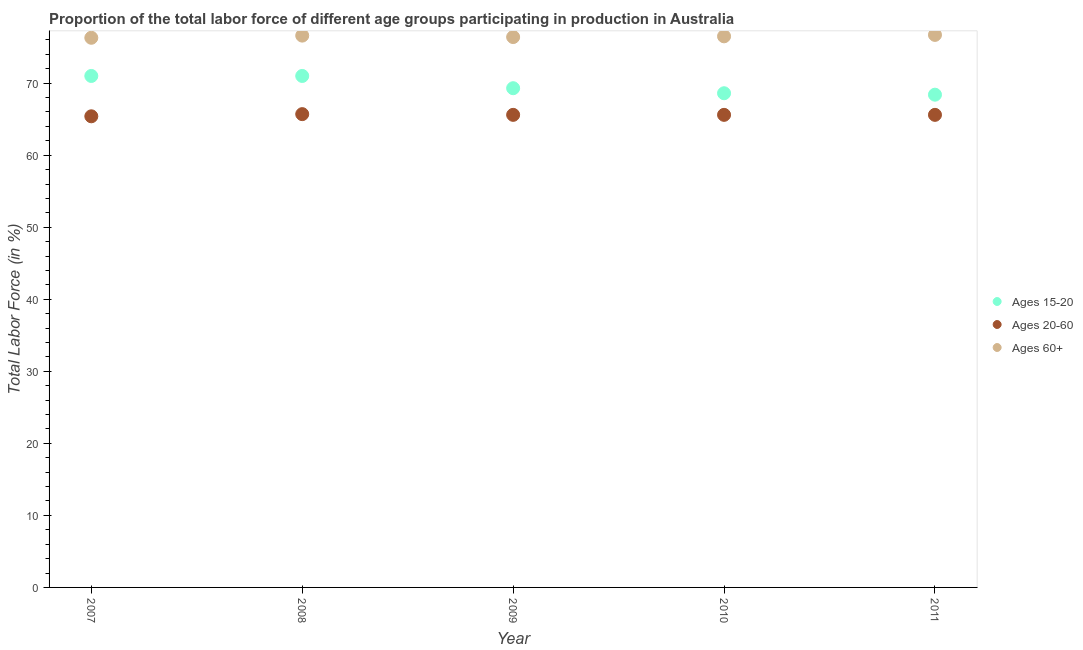How many different coloured dotlines are there?
Ensure brevity in your answer.  3. Is the number of dotlines equal to the number of legend labels?
Make the answer very short. Yes. What is the percentage of labor force above age 60 in 2007?
Keep it short and to the point. 76.3. Across all years, what is the maximum percentage of labor force above age 60?
Give a very brief answer. 76.7. Across all years, what is the minimum percentage of labor force within the age group 20-60?
Provide a succinct answer. 65.4. In which year was the percentage of labor force within the age group 15-20 maximum?
Offer a very short reply. 2007. What is the total percentage of labor force within the age group 20-60 in the graph?
Offer a terse response. 327.9. What is the difference between the percentage of labor force within the age group 20-60 in 2008 and that in 2009?
Make the answer very short. 0.1. What is the average percentage of labor force within the age group 20-60 per year?
Offer a very short reply. 65.58. In the year 2011, what is the difference between the percentage of labor force within the age group 20-60 and percentage of labor force above age 60?
Offer a very short reply. -11.1. What is the ratio of the percentage of labor force above age 60 in 2008 to that in 2011?
Provide a short and direct response. 1. What is the difference between the highest and the second highest percentage of labor force within the age group 20-60?
Your answer should be compact. 0.1. What is the difference between the highest and the lowest percentage of labor force within the age group 15-20?
Offer a terse response. 2.6. In how many years, is the percentage of labor force within the age group 20-60 greater than the average percentage of labor force within the age group 20-60 taken over all years?
Your answer should be compact. 4. Is the sum of the percentage of labor force within the age group 20-60 in 2009 and 2011 greater than the maximum percentage of labor force above age 60 across all years?
Offer a terse response. Yes. Is it the case that in every year, the sum of the percentage of labor force within the age group 15-20 and percentage of labor force within the age group 20-60 is greater than the percentage of labor force above age 60?
Provide a succinct answer. Yes. Is the percentage of labor force above age 60 strictly greater than the percentage of labor force within the age group 20-60 over the years?
Provide a succinct answer. Yes. Is the percentage of labor force within the age group 20-60 strictly less than the percentage of labor force within the age group 15-20 over the years?
Offer a very short reply. Yes. How many dotlines are there?
Offer a very short reply. 3. What is the difference between two consecutive major ticks on the Y-axis?
Make the answer very short. 10. Does the graph contain grids?
Your response must be concise. No. Where does the legend appear in the graph?
Make the answer very short. Center right. How many legend labels are there?
Your answer should be very brief. 3. What is the title of the graph?
Make the answer very short. Proportion of the total labor force of different age groups participating in production in Australia. What is the label or title of the X-axis?
Offer a very short reply. Year. What is the label or title of the Y-axis?
Ensure brevity in your answer.  Total Labor Force (in %). What is the Total Labor Force (in %) of Ages 20-60 in 2007?
Provide a short and direct response. 65.4. What is the Total Labor Force (in %) of Ages 60+ in 2007?
Your response must be concise. 76.3. What is the Total Labor Force (in %) in Ages 20-60 in 2008?
Provide a short and direct response. 65.7. What is the Total Labor Force (in %) in Ages 60+ in 2008?
Keep it short and to the point. 76.6. What is the Total Labor Force (in %) in Ages 15-20 in 2009?
Offer a terse response. 69.3. What is the Total Labor Force (in %) of Ages 20-60 in 2009?
Provide a succinct answer. 65.6. What is the Total Labor Force (in %) of Ages 60+ in 2009?
Your answer should be very brief. 76.4. What is the Total Labor Force (in %) of Ages 15-20 in 2010?
Give a very brief answer. 68.6. What is the Total Labor Force (in %) of Ages 20-60 in 2010?
Your answer should be compact. 65.6. What is the Total Labor Force (in %) in Ages 60+ in 2010?
Your answer should be compact. 76.5. What is the Total Labor Force (in %) in Ages 15-20 in 2011?
Keep it short and to the point. 68.4. What is the Total Labor Force (in %) in Ages 20-60 in 2011?
Keep it short and to the point. 65.6. What is the Total Labor Force (in %) of Ages 60+ in 2011?
Give a very brief answer. 76.7. Across all years, what is the maximum Total Labor Force (in %) of Ages 20-60?
Ensure brevity in your answer.  65.7. Across all years, what is the maximum Total Labor Force (in %) of Ages 60+?
Offer a very short reply. 76.7. Across all years, what is the minimum Total Labor Force (in %) in Ages 15-20?
Keep it short and to the point. 68.4. Across all years, what is the minimum Total Labor Force (in %) in Ages 20-60?
Offer a terse response. 65.4. Across all years, what is the minimum Total Labor Force (in %) of Ages 60+?
Your response must be concise. 76.3. What is the total Total Labor Force (in %) of Ages 15-20 in the graph?
Provide a succinct answer. 348.3. What is the total Total Labor Force (in %) of Ages 20-60 in the graph?
Give a very brief answer. 327.9. What is the total Total Labor Force (in %) in Ages 60+ in the graph?
Offer a very short reply. 382.5. What is the difference between the Total Labor Force (in %) in Ages 15-20 in 2007 and that in 2010?
Offer a terse response. 2.4. What is the difference between the Total Labor Force (in %) in Ages 60+ in 2007 and that in 2010?
Offer a terse response. -0.2. What is the difference between the Total Labor Force (in %) of Ages 20-60 in 2008 and that in 2009?
Make the answer very short. 0.1. What is the difference between the Total Labor Force (in %) in Ages 15-20 in 2008 and that in 2010?
Your answer should be very brief. 2.4. What is the difference between the Total Labor Force (in %) in Ages 20-60 in 2008 and that in 2010?
Your response must be concise. 0.1. What is the difference between the Total Labor Force (in %) of Ages 20-60 in 2008 and that in 2011?
Provide a short and direct response. 0.1. What is the difference between the Total Labor Force (in %) in Ages 60+ in 2008 and that in 2011?
Your response must be concise. -0.1. What is the difference between the Total Labor Force (in %) in Ages 15-20 in 2009 and that in 2010?
Keep it short and to the point. 0.7. What is the difference between the Total Labor Force (in %) of Ages 60+ in 2009 and that in 2011?
Your answer should be very brief. -0.3. What is the difference between the Total Labor Force (in %) in Ages 15-20 in 2010 and that in 2011?
Your answer should be compact. 0.2. What is the difference between the Total Labor Force (in %) of Ages 20-60 in 2010 and that in 2011?
Offer a terse response. 0. What is the difference between the Total Labor Force (in %) of Ages 20-60 in 2007 and the Total Labor Force (in %) of Ages 60+ in 2008?
Provide a succinct answer. -11.2. What is the difference between the Total Labor Force (in %) of Ages 15-20 in 2007 and the Total Labor Force (in %) of Ages 60+ in 2009?
Provide a short and direct response. -5.4. What is the difference between the Total Labor Force (in %) in Ages 20-60 in 2007 and the Total Labor Force (in %) in Ages 60+ in 2009?
Your response must be concise. -11. What is the difference between the Total Labor Force (in %) of Ages 15-20 in 2007 and the Total Labor Force (in %) of Ages 20-60 in 2010?
Keep it short and to the point. 5.4. What is the difference between the Total Labor Force (in %) in Ages 15-20 in 2007 and the Total Labor Force (in %) in Ages 60+ in 2010?
Offer a terse response. -5.5. What is the difference between the Total Labor Force (in %) in Ages 15-20 in 2008 and the Total Labor Force (in %) in Ages 20-60 in 2009?
Your response must be concise. 5.4. What is the difference between the Total Labor Force (in %) of Ages 15-20 in 2008 and the Total Labor Force (in %) of Ages 60+ in 2009?
Provide a succinct answer. -5.4. What is the difference between the Total Labor Force (in %) of Ages 20-60 in 2008 and the Total Labor Force (in %) of Ages 60+ in 2009?
Your answer should be compact. -10.7. What is the difference between the Total Labor Force (in %) in Ages 15-20 in 2008 and the Total Labor Force (in %) in Ages 20-60 in 2011?
Provide a short and direct response. 5.4. What is the difference between the Total Labor Force (in %) in Ages 20-60 in 2008 and the Total Labor Force (in %) in Ages 60+ in 2011?
Offer a terse response. -11. What is the difference between the Total Labor Force (in %) of Ages 15-20 in 2009 and the Total Labor Force (in %) of Ages 20-60 in 2010?
Give a very brief answer. 3.7. What is the difference between the Total Labor Force (in %) in Ages 15-20 in 2009 and the Total Labor Force (in %) in Ages 20-60 in 2011?
Offer a terse response. 3.7. What is the difference between the Total Labor Force (in %) in Ages 20-60 in 2009 and the Total Labor Force (in %) in Ages 60+ in 2011?
Provide a short and direct response. -11.1. What is the difference between the Total Labor Force (in %) of Ages 15-20 in 2010 and the Total Labor Force (in %) of Ages 60+ in 2011?
Offer a very short reply. -8.1. What is the difference between the Total Labor Force (in %) in Ages 20-60 in 2010 and the Total Labor Force (in %) in Ages 60+ in 2011?
Give a very brief answer. -11.1. What is the average Total Labor Force (in %) in Ages 15-20 per year?
Ensure brevity in your answer.  69.66. What is the average Total Labor Force (in %) of Ages 20-60 per year?
Ensure brevity in your answer.  65.58. What is the average Total Labor Force (in %) in Ages 60+ per year?
Your answer should be compact. 76.5. In the year 2007, what is the difference between the Total Labor Force (in %) of Ages 15-20 and Total Labor Force (in %) of Ages 20-60?
Your answer should be compact. 5.6. In the year 2008, what is the difference between the Total Labor Force (in %) in Ages 15-20 and Total Labor Force (in %) in Ages 20-60?
Keep it short and to the point. 5.3. In the year 2008, what is the difference between the Total Labor Force (in %) of Ages 15-20 and Total Labor Force (in %) of Ages 60+?
Make the answer very short. -5.6. In the year 2008, what is the difference between the Total Labor Force (in %) of Ages 20-60 and Total Labor Force (in %) of Ages 60+?
Your answer should be very brief. -10.9. In the year 2009, what is the difference between the Total Labor Force (in %) of Ages 15-20 and Total Labor Force (in %) of Ages 20-60?
Your answer should be compact. 3.7. In the year 2009, what is the difference between the Total Labor Force (in %) of Ages 20-60 and Total Labor Force (in %) of Ages 60+?
Offer a terse response. -10.8. In the year 2010, what is the difference between the Total Labor Force (in %) of Ages 15-20 and Total Labor Force (in %) of Ages 20-60?
Your response must be concise. 3. In the year 2010, what is the difference between the Total Labor Force (in %) in Ages 15-20 and Total Labor Force (in %) in Ages 60+?
Ensure brevity in your answer.  -7.9. In the year 2011, what is the difference between the Total Labor Force (in %) in Ages 20-60 and Total Labor Force (in %) in Ages 60+?
Ensure brevity in your answer.  -11.1. What is the ratio of the Total Labor Force (in %) in Ages 60+ in 2007 to that in 2008?
Make the answer very short. 1. What is the ratio of the Total Labor Force (in %) in Ages 15-20 in 2007 to that in 2009?
Make the answer very short. 1.02. What is the ratio of the Total Labor Force (in %) of Ages 60+ in 2007 to that in 2009?
Offer a terse response. 1. What is the ratio of the Total Labor Force (in %) of Ages 15-20 in 2007 to that in 2010?
Provide a succinct answer. 1.03. What is the ratio of the Total Labor Force (in %) in Ages 20-60 in 2007 to that in 2010?
Ensure brevity in your answer.  1. What is the ratio of the Total Labor Force (in %) in Ages 60+ in 2007 to that in 2010?
Provide a short and direct response. 1. What is the ratio of the Total Labor Force (in %) of Ages 15-20 in 2007 to that in 2011?
Your answer should be compact. 1.04. What is the ratio of the Total Labor Force (in %) in Ages 20-60 in 2007 to that in 2011?
Your answer should be compact. 1. What is the ratio of the Total Labor Force (in %) in Ages 15-20 in 2008 to that in 2009?
Your response must be concise. 1.02. What is the ratio of the Total Labor Force (in %) of Ages 60+ in 2008 to that in 2009?
Your answer should be very brief. 1. What is the ratio of the Total Labor Force (in %) of Ages 15-20 in 2008 to that in 2010?
Your response must be concise. 1.03. What is the ratio of the Total Labor Force (in %) of Ages 60+ in 2008 to that in 2010?
Ensure brevity in your answer.  1. What is the ratio of the Total Labor Force (in %) in Ages 15-20 in 2008 to that in 2011?
Give a very brief answer. 1.04. What is the ratio of the Total Labor Force (in %) of Ages 20-60 in 2008 to that in 2011?
Give a very brief answer. 1. What is the ratio of the Total Labor Force (in %) of Ages 15-20 in 2009 to that in 2010?
Your response must be concise. 1.01. What is the ratio of the Total Labor Force (in %) in Ages 15-20 in 2009 to that in 2011?
Ensure brevity in your answer.  1.01. What is the ratio of the Total Labor Force (in %) of Ages 60+ in 2009 to that in 2011?
Offer a terse response. 1. What is the ratio of the Total Labor Force (in %) in Ages 15-20 in 2010 to that in 2011?
Offer a terse response. 1. What is the ratio of the Total Labor Force (in %) of Ages 60+ in 2010 to that in 2011?
Make the answer very short. 1. What is the difference between the highest and the lowest Total Labor Force (in %) of Ages 15-20?
Offer a terse response. 2.6. What is the difference between the highest and the lowest Total Labor Force (in %) of Ages 60+?
Ensure brevity in your answer.  0.4. 